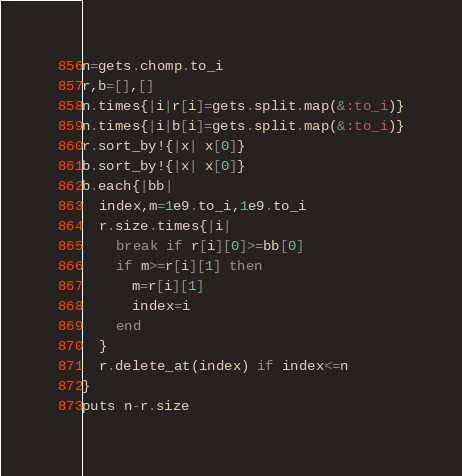Convert code to text. <code><loc_0><loc_0><loc_500><loc_500><_Ruby_>n=gets.chomp.to_i
r,b=[],[]
n.times{|i|r[i]=gets.split.map(&:to_i)}
n.times{|i|b[i]=gets.split.map(&:to_i)}
r.sort_by!{|x| x[0]}
b.sort_by!{|x| x[0]}
b.each{|bb|
  index,m=1e9.to_i,1e9.to_i
  r.size.times{|i|
    break if r[i][0]>=bb[0]
    if m>=r[i][1] then
      m=r[i][1]
      index=i
    end
  }
  r.delete_at(index) if index<=n
}
puts n-r.size
</code> 